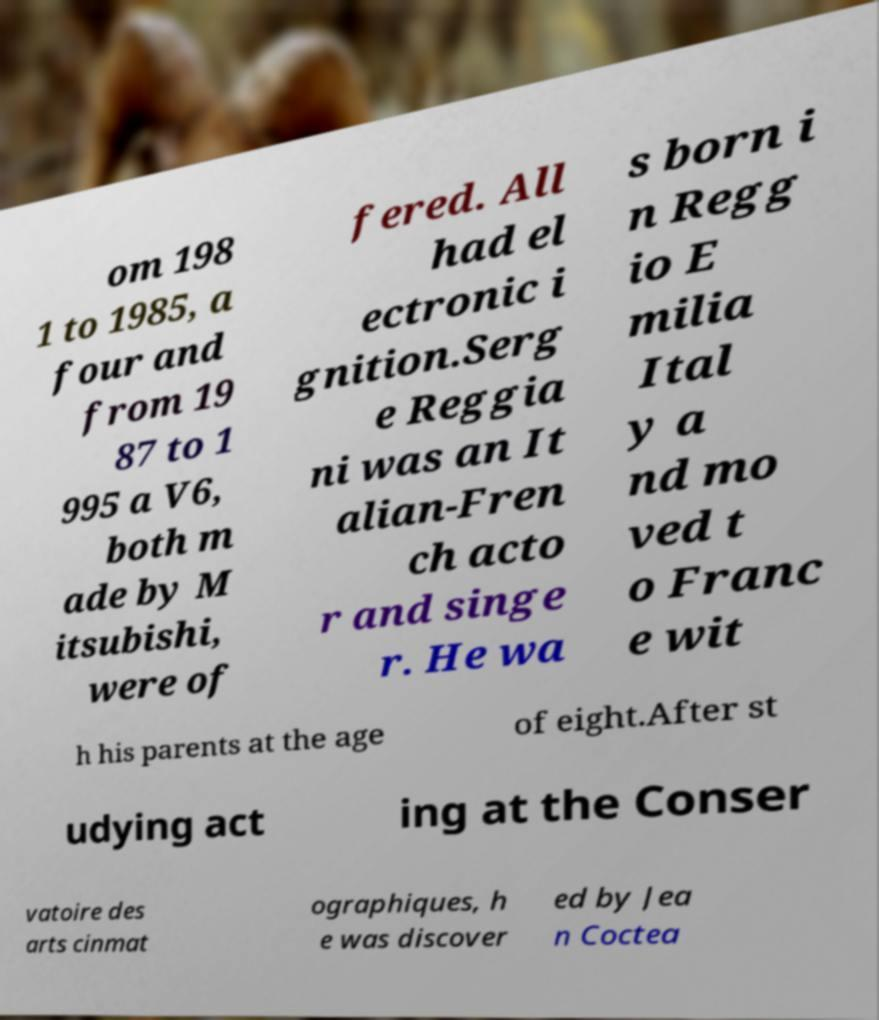Could you extract and type out the text from this image? om 198 1 to 1985, a four and from 19 87 to 1 995 a V6, both m ade by M itsubishi, were of fered. All had el ectronic i gnition.Serg e Reggia ni was an It alian-Fren ch acto r and singe r. He wa s born i n Regg io E milia Ital y a nd mo ved t o Franc e wit h his parents at the age of eight.After st udying act ing at the Conser vatoire des arts cinmat ographiques, h e was discover ed by Jea n Coctea 